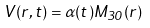Convert formula to latex. <formula><loc_0><loc_0><loc_500><loc_500>V ( r , t ) = \alpha ( t ) M _ { 3 0 } ( r )</formula> 